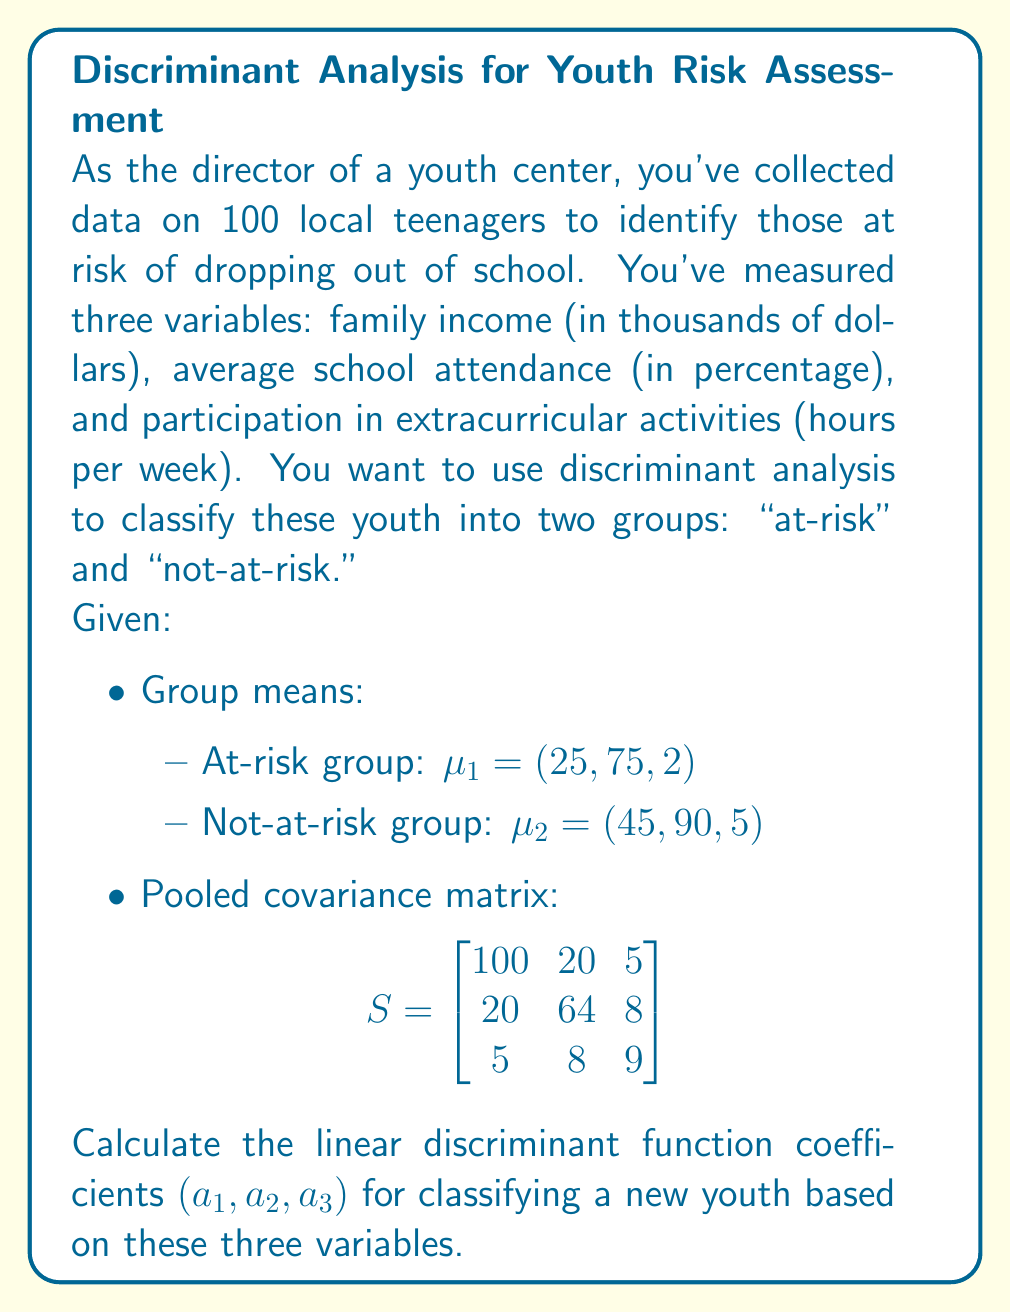Provide a solution to this math problem. To find the linear discriminant function coefficients, we'll follow these steps:

1) The linear discriminant function is given by:
   $a'x = a_1x_1 + a_2x_2 + a_3x_3$

2) The coefficient vector $a$ is calculated using:
   $a = S^{-1}(\mu_2 - \mu_1)$

3) First, let's calculate $(\mu_2 - \mu_1)$:
   $\mu_2 - \mu_1 = (45, 90, 5) - (25, 75, 2) = (20, 15, 3)$

4) Now, we need to find $S^{-1}$. We can use a calculator or computer for this:
   $$S^{-1} = \begin{bmatrix}
   0.0106 & -0.0033 & -0.0058 \\
   -0.0033 & 0.0167 & -0.0139 \\
   -0.0058 & -0.0139 & 0.1209
   \end{bmatrix}$$

5) Finally, we multiply $S^{-1}$ by $(\mu_2 - \mu_1)$:
   $$a = \begin{bmatrix}
   0.0106 & -0.0033 & -0.0058 \\
   -0.0033 & 0.0167 & -0.0139 \\
   -0.0058 & -0.0139 & 0.1209
   \end{bmatrix} \begin{bmatrix}
   20 \\
   15 \\
   3
   \end{bmatrix}$$

6) Performing this matrix multiplication:
   $a_1 = 0.0106(20) + (-0.0033)(15) + (-0.0058)(3) = 0.1645$
   $a_2 = (-0.0033)(20) + 0.0167(15) + (-0.0139)(3) = 0.1858$
   $a_3 = (-0.0058)(20) + (-0.0139)(15) + 0.1209(3) = 0.1855$

Therefore, the linear discriminant function coefficients are $(0.1645, 0.1858, 0.1855)$.
Answer: $(0.1645, 0.1858, 0.1855)$ 